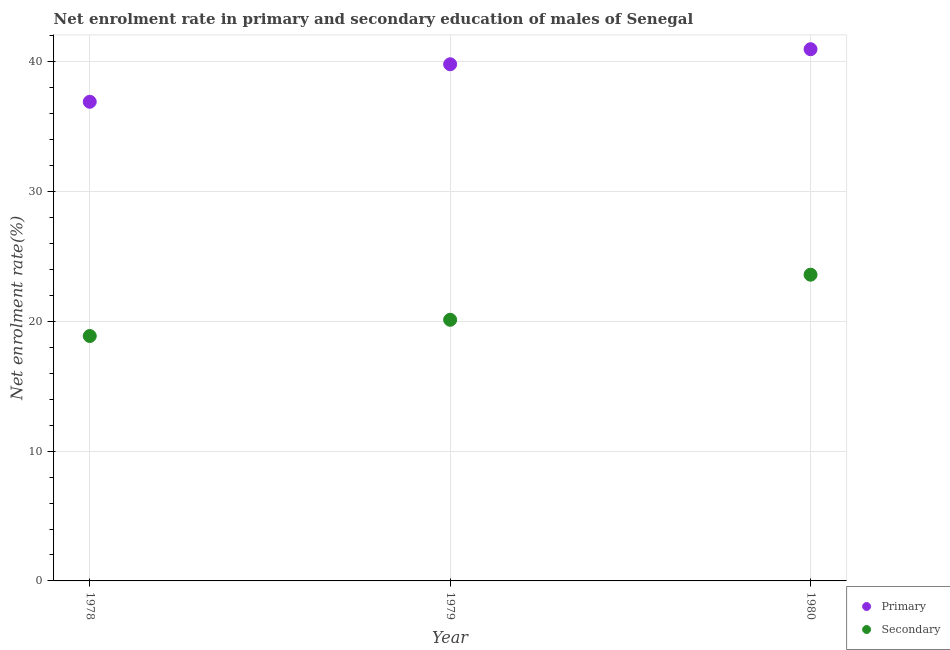How many different coloured dotlines are there?
Make the answer very short. 2. What is the enrollment rate in secondary education in 1980?
Keep it short and to the point. 23.6. Across all years, what is the maximum enrollment rate in primary education?
Offer a terse response. 40.98. Across all years, what is the minimum enrollment rate in secondary education?
Make the answer very short. 18.87. In which year was the enrollment rate in secondary education minimum?
Provide a succinct answer. 1978. What is the total enrollment rate in primary education in the graph?
Offer a terse response. 117.72. What is the difference between the enrollment rate in primary education in 1978 and that in 1980?
Keep it short and to the point. -4.05. What is the difference between the enrollment rate in primary education in 1979 and the enrollment rate in secondary education in 1980?
Ensure brevity in your answer.  16.22. What is the average enrollment rate in primary education per year?
Keep it short and to the point. 39.24. In the year 1979, what is the difference between the enrollment rate in secondary education and enrollment rate in primary education?
Provide a succinct answer. -19.69. In how many years, is the enrollment rate in primary education greater than 32 %?
Give a very brief answer. 3. What is the ratio of the enrollment rate in secondary education in 1978 to that in 1980?
Offer a terse response. 0.8. What is the difference between the highest and the second highest enrollment rate in primary education?
Your answer should be very brief. 1.16. What is the difference between the highest and the lowest enrollment rate in primary education?
Provide a short and direct response. 4.05. Is the enrollment rate in primary education strictly greater than the enrollment rate in secondary education over the years?
Your answer should be very brief. Yes. How many dotlines are there?
Offer a terse response. 2. Are the values on the major ticks of Y-axis written in scientific E-notation?
Make the answer very short. No. Does the graph contain any zero values?
Offer a very short reply. No. Where does the legend appear in the graph?
Ensure brevity in your answer.  Bottom right. What is the title of the graph?
Provide a short and direct response. Net enrolment rate in primary and secondary education of males of Senegal. Does "From production" appear as one of the legend labels in the graph?
Ensure brevity in your answer.  No. What is the label or title of the X-axis?
Your answer should be very brief. Year. What is the label or title of the Y-axis?
Keep it short and to the point. Net enrolment rate(%). What is the Net enrolment rate(%) in Primary in 1978?
Offer a terse response. 36.93. What is the Net enrolment rate(%) of Secondary in 1978?
Ensure brevity in your answer.  18.87. What is the Net enrolment rate(%) in Primary in 1979?
Keep it short and to the point. 39.82. What is the Net enrolment rate(%) of Secondary in 1979?
Your response must be concise. 20.13. What is the Net enrolment rate(%) in Primary in 1980?
Provide a succinct answer. 40.98. What is the Net enrolment rate(%) of Secondary in 1980?
Provide a short and direct response. 23.6. Across all years, what is the maximum Net enrolment rate(%) in Primary?
Make the answer very short. 40.98. Across all years, what is the maximum Net enrolment rate(%) in Secondary?
Provide a succinct answer. 23.6. Across all years, what is the minimum Net enrolment rate(%) of Primary?
Your response must be concise. 36.93. Across all years, what is the minimum Net enrolment rate(%) of Secondary?
Keep it short and to the point. 18.87. What is the total Net enrolment rate(%) of Primary in the graph?
Offer a terse response. 117.72. What is the total Net enrolment rate(%) of Secondary in the graph?
Your response must be concise. 62.6. What is the difference between the Net enrolment rate(%) of Primary in 1978 and that in 1979?
Your answer should be very brief. -2.89. What is the difference between the Net enrolment rate(%) in Secondary in 1978 and that in 1979?
Offer a very short reply. -1.25. What is the difference between the Net enrolment rate(%) of Primary in 1978 and that in 1980?
Your answer should be compact. -4.05. What is the difference between the Net enrolment rate(%) of Secondary in 1978 and that in 1980?
Offer a terse response. -4.73. What is the difference between the Net enrolment rate(%) of Primary in 1979 and that in 1980?
Your response must be concise. -1.16. What is the difference between the Net enrolment rate(%) in Secondary in 1979 and that in 1980?
Give a very brief answer. -3.47. What is the difference between the Net enrolment rate(%) of Primary in 1978 and the Net enrolment rate(%) of Secondary in 1979?
Your answer should be very brief. 16.8. What is the difference between the Net enrolment rate(%) of Primary in 1978 and the Net enrolment rate(%) of Secondary in 1980?
Offer a very short reply. 13.33. What is the difference between the Net enrolment rate(%) in Primary in 1979 and the Net enrolment rate(%) in Secondary in 1980?
Keep it short and to the point. 16.22. What is the average Net enrolment rate(%) in Primary per year?
Keep it short and to the point. 39.24. What is the average Net enrolment rate(%) in Secondary per year?
Keep it short and to the point. 20.87. In the year 1978, what is the difference between the Net enrolment rate(%) in Primary and Net enrolment rate(%) in Secondary?
Provide a short and direct response. 18.05. In the year 1979, what is the difference between the Net enrolment rate(%) of Primary and Net enrolment rate(%) of Secondary?
Your response must be concise. 19.69. In the year 1980, what is the difference between the Net enrolment rate(%) in Primary and Net enrolment rate(%) in Secondary?
Ensure brevity in your answer.  17.38. What is the ratio of the Net enrolment rate(%) in Primary in 1978 to that in 1979?
Keep it short and to the point. 0.93. What is the ratio of the Net enrolment rate(%) of Secondary in 1978 to that in 1979?
Keep it short and to the point. 0.94. What is the ratio of the Net enrolment rate(%) in Primary in 1978 to that in 1980?
Your answer should be very brief. 0.9. What is the ratio of the Net enrolment rate(%) of Secondary in 1978 to that in 1980?
Ensure brevity in your answer.  0.8. What is the ratio of the Net enrolment rate(%) in Primary in 1979 to that in 1980?
Provide a short and direct response. 0.97. What is the ratio of the Net enrolment rate(%) in Secondary in 1979 to that in 1980?
Provide a short and direct response. 0.85. What is the difference between the highest and the second highest Net enrolment rate(%) of Primary?
Your answer should be compact. 1.16. What is the difference between the highest and the second highest Net enrolment rate(%) in Secondary?
Your answer should be very brief. 3.47. What is the difference between the highest and the lowest Net enrolment rate(%) in Primary?
Your answer should be very brief. 4.05. What is the difference between the highest and the lowest Net enrolment rate(%) of Secondary?
Your response must be concise. 4.73. 